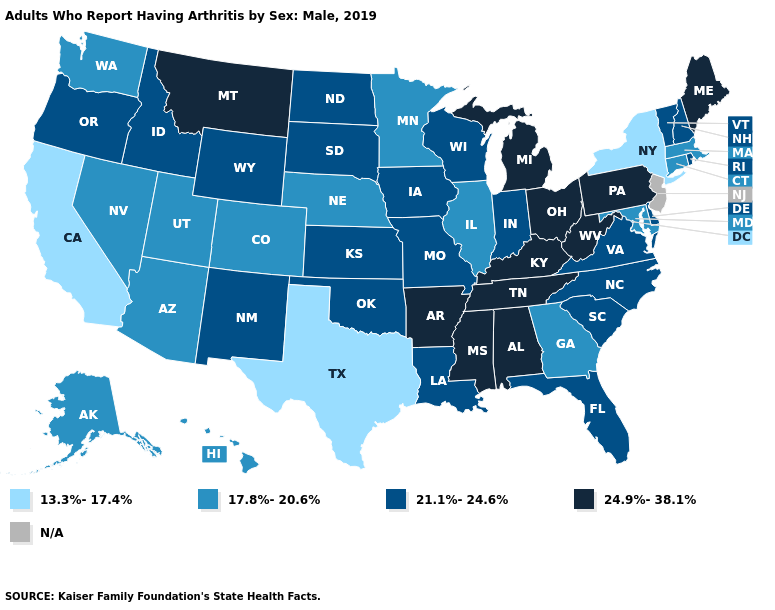Name the states that have a value in the range N/A?
Keep it brief. New Jersey. Name the states that have a value in the range 13.3%-17.4%?
Answer briefly. California, New York, Texas. Which states have the lowest value in the West?
Be succinct. California. What is the lowest value in the USA?
Give a very brief answer. 13.3%-17.4%. Which states have the highest value in the USA?
Short answer required. Alabama, Arkansas, Kentucky, Maine, Michigan, Mississippi, Montana, Ohio, Pennsylvania, Tennessee, West Virginia. What is the lowest value in the USA?
Concise answer only. 13.3%-17.4%. Name the states that have a value in the range 13.3%-17.4%?
Write a very short answer. California, New York, Texas. What is the value of West Virginia?
Give a very brief answer. 24.9%-38.1%. Does Texas have the lowest value in the USA?
Be succinct. Yes. Name the states that have a value in the range 21.1%-24.6%?
Answer briefly. Delaware, Florida, Idaho, Indiana, Iowa, Kansas, Louisiana, Missouri, New Hampshire, New Mexico, North Carolina, North Dakota, Oklahoma, Oregon, Rhode Island, South Carolina, South Dakota, Vermont, Virginia, Wisconsin, Wyoming. Among the states that border New Jersey , which have the lowest value?
Be succinct. New York. 